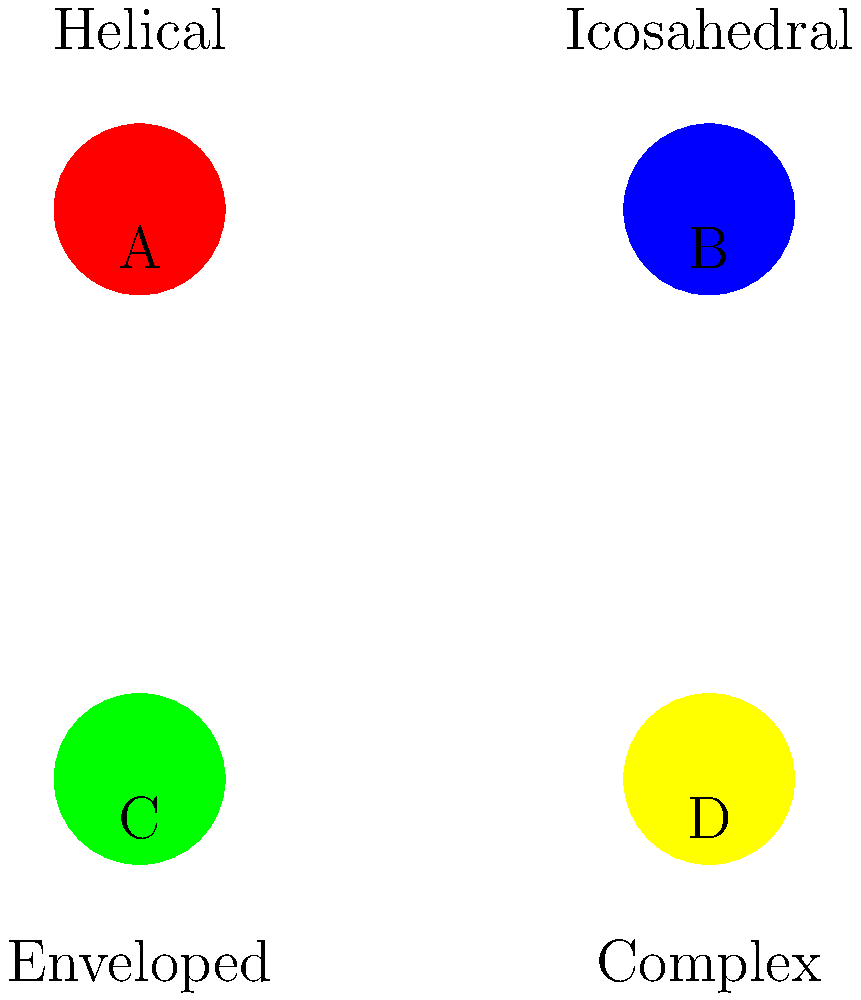Based on the electron microscope images of different virus structures shown above, which shape corresponds to a typical influenza virus? To answer this question, let's analyze each virus structure:

1. Structure A (Red): This represents a helical virus structure. Helical viruses have a coiled nucleic acid surrounded by a protein coat, forming a rod-like shape.

2. Structure B (Blue): This shows an icosahedral virus structure. Icosahedral viruses have a symmetrical, roughly spherical shape with 20 triangular faces.

3. Structure C (Green): This illustrates an enveloped virus structure. Enveloped viruses have a lipid bilayer surrounding their protein capsid, often appearing as a spherical shape with surface projections.

4. Structure D (Yellow): This depicts a complex virus structure, which has a more intricate shape that doesn't fit into the other categories.

Influenza viruses are known to be enveloped viruses. They have a lipid bilayer envelope derived from the host cell membrane, with spike-like glycoproteins (hemagglutinin and neuraminidase) protruding from the surface. This structure is best represented by the enveloped virus image.
Answer: C (Enveloped) 